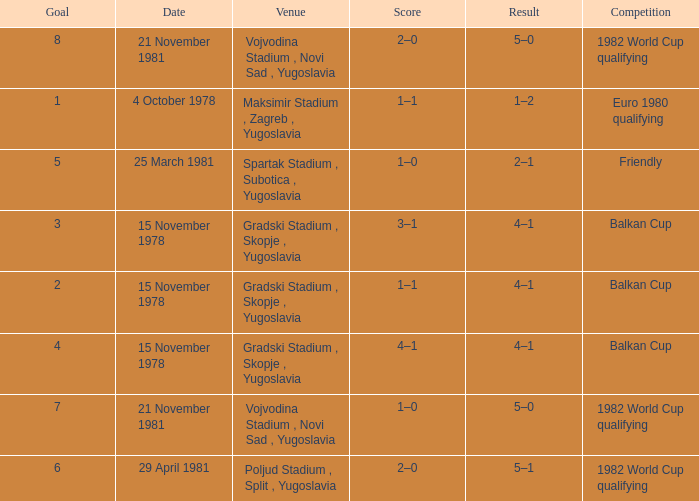What is the outcome of goal 3? 4–1. 